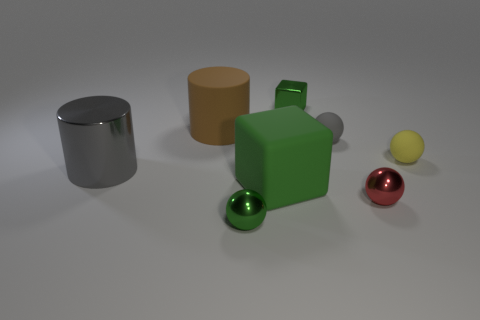Imagine these objects are part of a learning kit. What could be the purpose of such a kit? If these items are part of a learning kit, they could serve as aids for a variety of educational themes. Their different shapes, sizes, and materials could be used to teach basic geometry, properties of materials, colors, light reflection and absorption, and spatial relationships. They'd be particularly useful in a hands-on learning environment where tactile experience can reinforce visual instruction. 